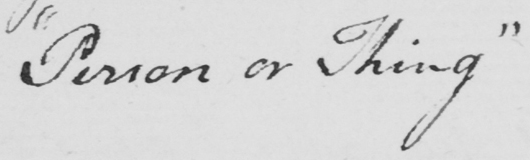What text is written in this handwritten line? " Person or Thing " 